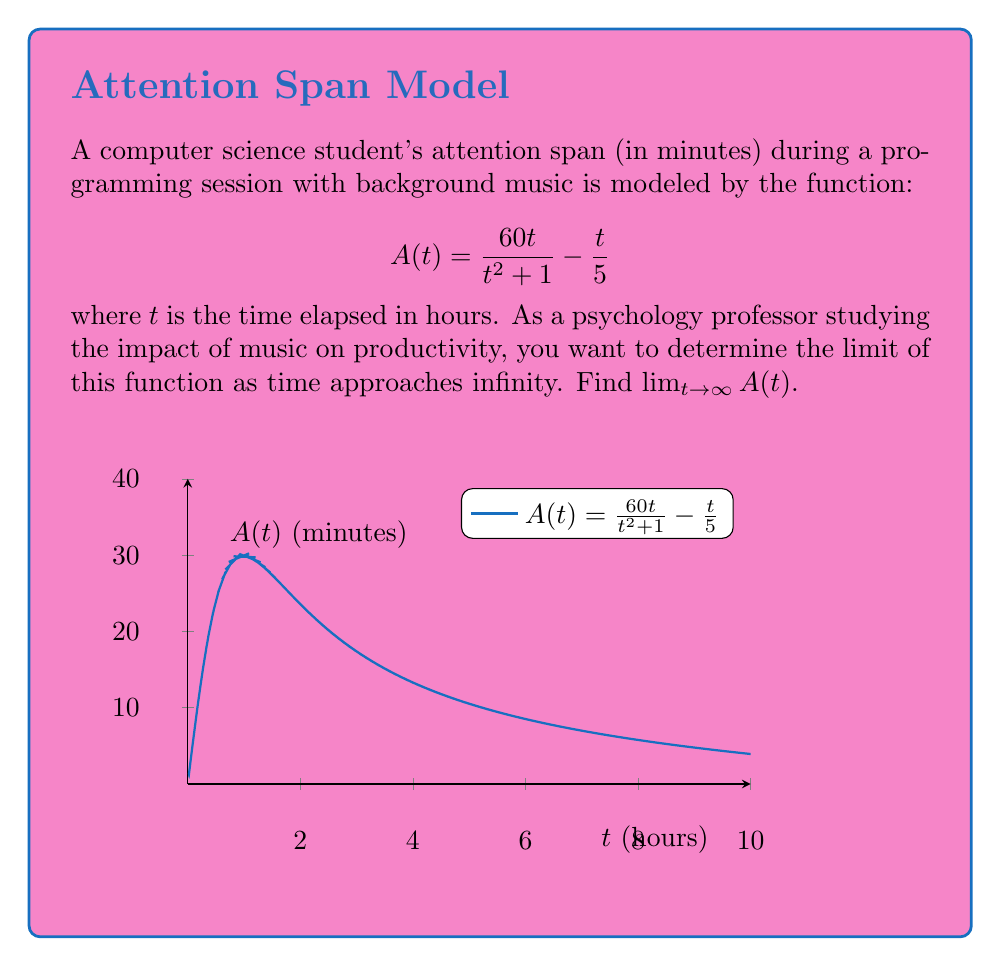Can you solve this math problem? To find the limit as $t$ approaches infinity, we'll follow these steps:

1) First, let's consider the behavior of each term separately as $t \to \infty$:

   For $\frac{60t}{t^2 + 1}$:
   $$\lim_{t \to \infty} \frac{60t}{t^2 + 1} = \lim_{t \to \infty} \frac{60}{t + \frac{1}{t}} = 0$$

   For $\frac{t}{5}$:
   $$\lim_{t \to \infty} \frac{t}{5} = \infty$$

2) Now, let's combine these results:

   $$\lim_{t \to \infty} A(t) = \lim_{t \to \infty} \left(\frac{60t}{t^2 + 1} - \frac{t}{5}\right)$$

3) We can't simply subtract infinity from zero, so we need to find a common denominator:

   $$\lim_{t \to \infty} \frac{60t(5) - (t^2 + 1)(t)}{5(t^2 + 1)}$$

4) Simplify the numerator:

   $$\lim_{t \to \infty} \frac{300t - t^3 - t}{5(t^2 + 1)}$$

5) Factor out the highest power of $t$ from numerator and denominator:

   $$\lim_{t \to \infty} \frac{t(-t^2 + 300 - 1)}{5t^2(1 + \frac{1}{t^2})}$$

6) Cancel $t$ from numerator and denominator:

   $$\lim_{t \to \infty} \frac{-t^2 + 299}{5t^2(1 + \frac{1}{t^2})}$$

7) As $t \to \infty$, $\frac{1}{t^2} \to 0$ and $\frac{299}{t^2} \to 0$, so:

   $$\lim_{t \to \infty} \frac{-t^2}{5t^2} = -\frac{1}{5}$$

Therefore, the limit of the attention span function as time approaches infinity is $-\frac{1}{5}$ or $-0.2$ minutes.
Answer: $-\frac{1}{5}$ minutes 